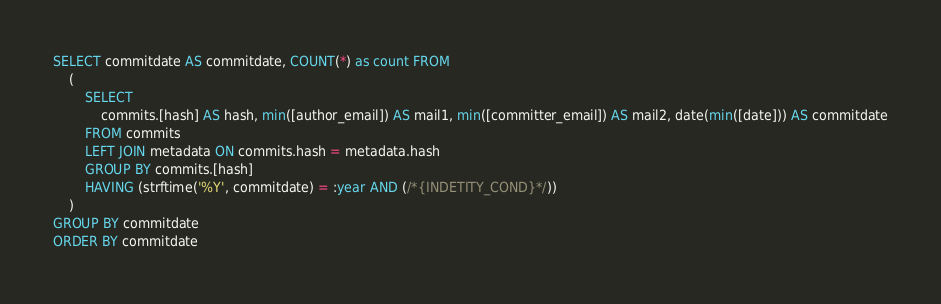Convert code to text. <code><loc_0><loc_0><loc_500><loc_500><_SQL_>SELECT commitdate AS commitdate, COUNT(*) as count FROM
	(
		SELECT
			commits.[hash] AS hash, min([author_email]) AS mail1, min([committer_email]) AS mail2, date(min([date])) AS commitdate
		FROM commits
		LEFT JOIN metadata ON commits.hash = metadata.hash
		GROUP BY commits.[hash]
		HAVING (strftime('%Y', commitdate) = :year AND (/*{INDETITY_COND}*/))
	)
GROUP BY commitdate
ORDER BY commitdate</code> 